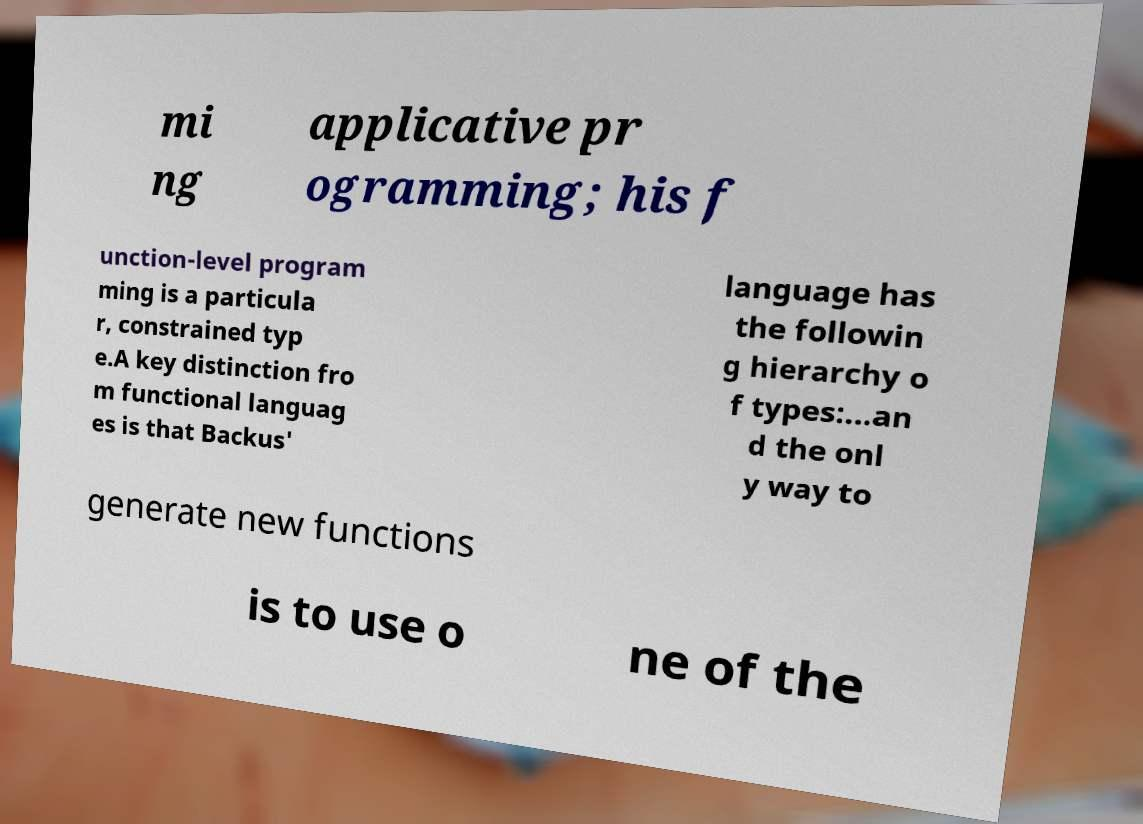Can you read and provide the text displayed in the image?This photo seems to have some interesting text. Can you extract and type it out for me? mi ng applicative pr ogramming; his f unction-level program ming is a particula r, constrained typ e.A key distinction fro m functional languag es is that Backus' language has the followin g hierarchy o f types:...an d the onl y way to generate new functions is to use o ne of the 